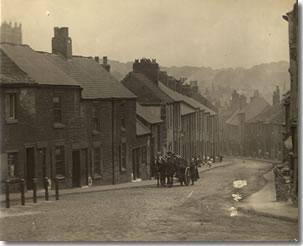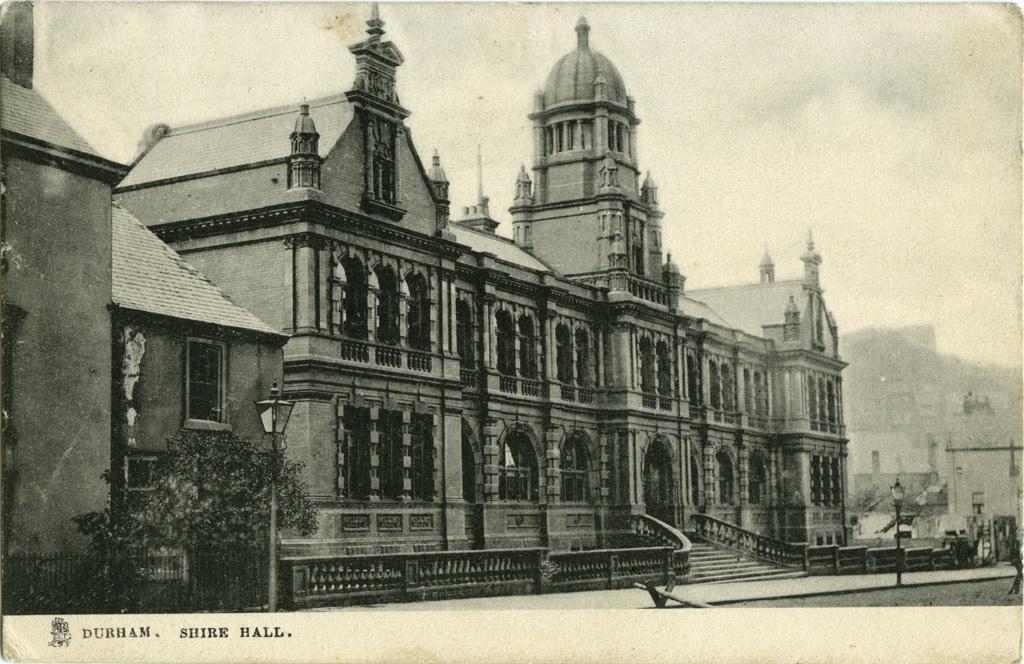The first image is the image on the left, the second image is the image on the right. Examine the images to the left and right. Is the description "A house with a landscaped lawn has a roof with at least three notches around windows on its front side facing the street." accurate? Answer yes or no. No. The first image is the image on the left, the second image is the image on the right. Analyze the images presented: Is the assertion "In at least one image there is a yellow bricked house facing forward right with two chimney." valid? Answer yes or no. No. 